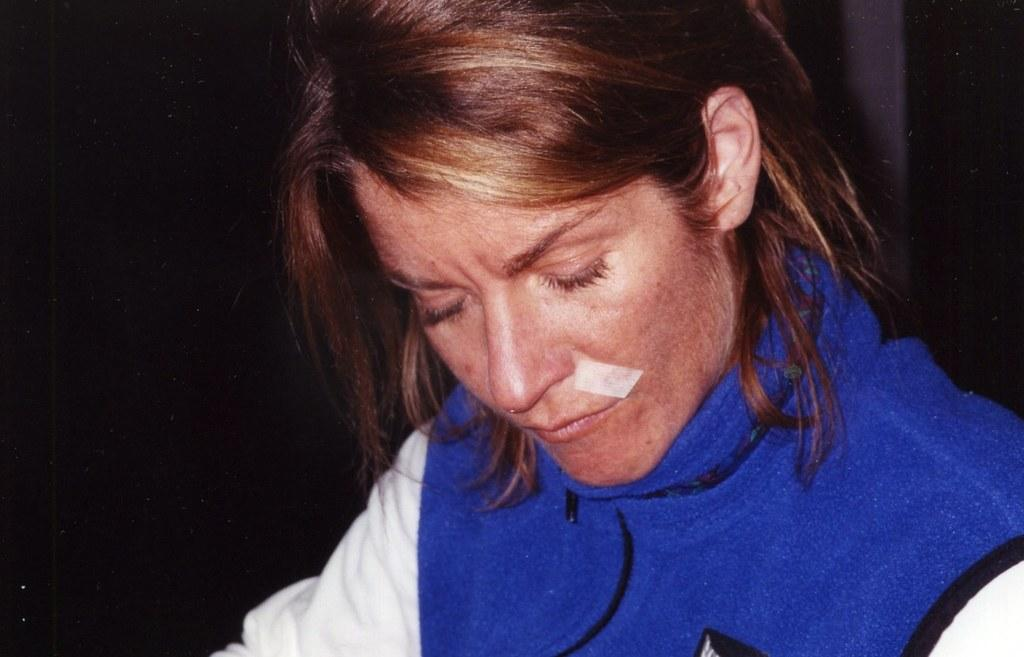Who is the main subject in the foreground of the image? There is a woman in the foreground of the image. What can be seen in the background of the image? There is a wall in the background of the image. What type of sticks can be seen being used for teaching in the image? There are no sticks or teaching activities present in the image. 